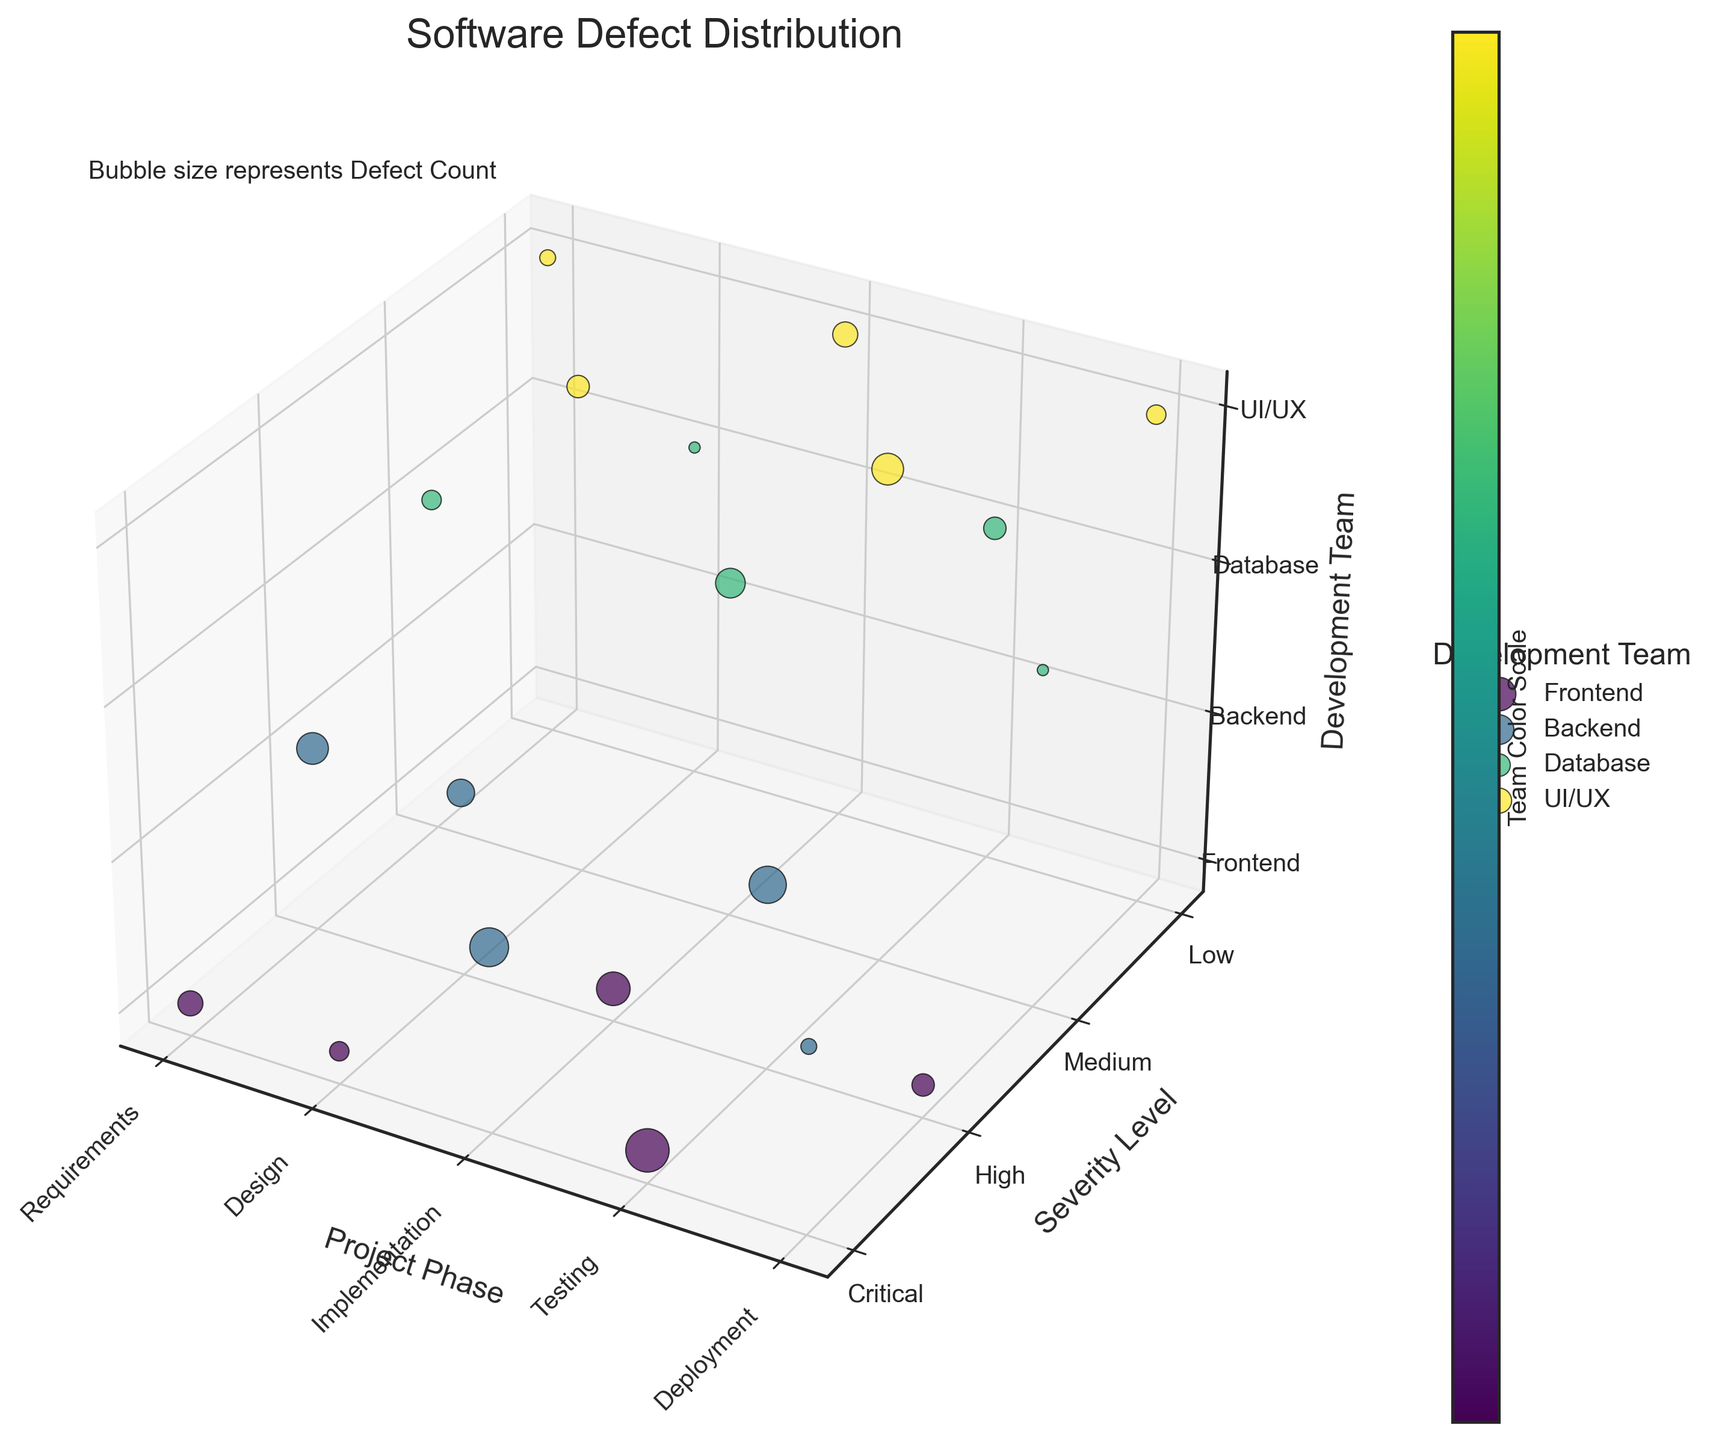What is the title of the chart? The title of the chart is displayed at the top of the figure, stating the main topic and context of the data visualization.
Answer: Software Defect Distribution Which project phase has the highest number of defects in the critical severity level? From the 3D bubble chart, we look for the bubbles representing the critical severity level on the y-axis. The largest bubble in the critical level shows the highest defect count. We find the defect count is highest in the Testing phase.
Answer: Testing Which development team has the highest number of defects in the implementation phase? We find the implementation phase on the x-axis and identify the color representing each team (based on the legend). The largest bubble in this phase indicates the team with the highest defects. The Backend team has the highest number.
Answer: Backend What is the sum of defect counts for the Backend team in the Testing and Implementation phases? Identify and sum the sizes of bubbles representing the Backend team (color-coded) in both the Testing and Implementation phases. Backend in Testing has 11 defects, and in Implementation has 12 defects. 11 + 12 = 23
Answer: 23 Compare the defect counts of the Frontend team in the Requirements and Testing phases. Which one is greater? Locate the Frontend team's bubbles in the Requirements and Testing phases, then compare their sizes. The Testing phase has a bubble with 15 defects, while the Requirements phase has a bubble with 5 defects. The Testing phase has more.
Answer: Testing What is the average defect count for the UI/UX team across all project phases? Find bubbles for the UI/UX team across all phases, sum their defect counts, and divide by the number of bubbles. UI/UX has 2 in Requirements, 4 in Design, 5 in Implementation, 8 in Testing, and 3 in Deployment. Sum is 2 + 4 + 5 + 8 + 3 = 22. The number of phases is 5. Average is 22 / 5 = 4.4
Answer: 4.4 Which severity level has the most consistent defect count across all phases for the Database team? Assessing bubbles for the Database team (color-coded) in each severity level, we examine the sizes for consistency. Medium severity has 3, 1, 7, 4, and 1 defects which is relatively consistent compared to other levels.
Answer: Medium How many total defects are there in the Design phase across all teams? Evaluate all bubbles in the Design phase, regardless of team, and sum their defect counts. Frontend has 3, Backend 6, UI/UX 4, and Database 1. Total is 3 + 6 + 4 + 1 = 14
Answer: 14 Which team has the lowest number of defects in the Critical severity level across all phases? Scan all rows for the Critical severity and identify the smallest bubbles for the teams. The Backend team in the Deployment phase has 2 defects, which is the lowest in this severity level.
Answer: Backend What is the total number of defects for the Frontend team across all phases and severity levels? Sum the defect counts from all bubbles associated with the Frontend team across all phases. Values are 5 (Requirements), 3 (Design), 9 (Implementation), 15 (Testing), and 4 (Deployment). Total is 5 + 3 + 9 + 15 + 4 = 36
Answer: 36 